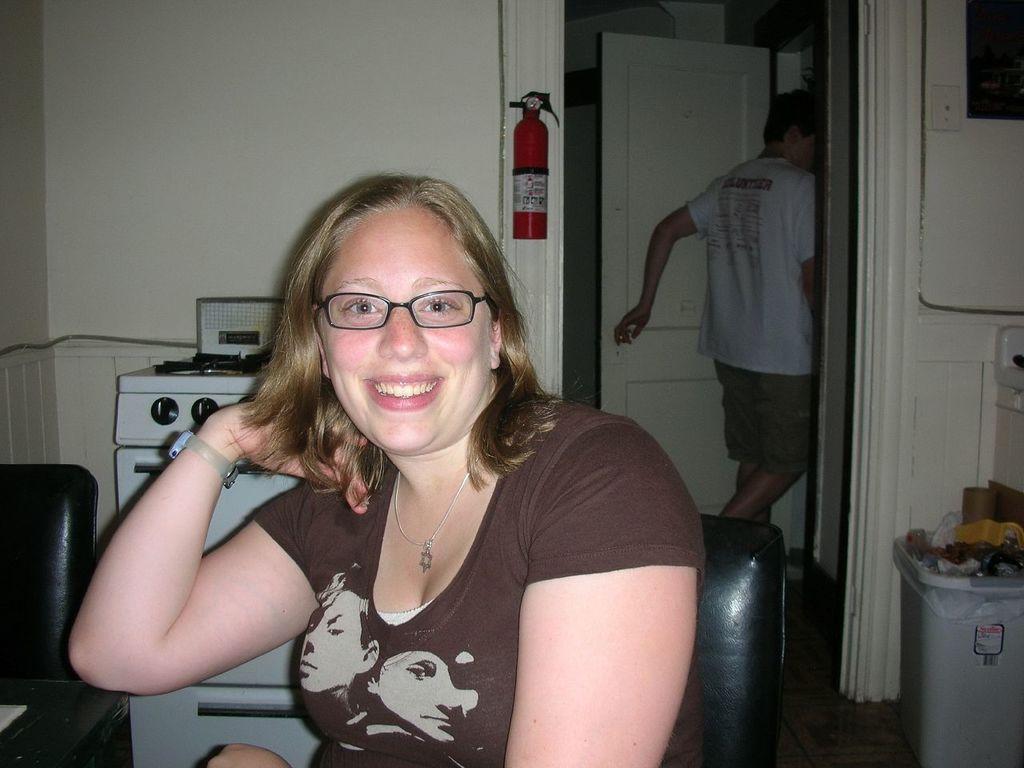In one or two sentences, can you explain what this image depicts? There is a woman in brown color t-shirt smiling and sitting on a chair near a stove and table. In the background, there is a dustbin on the floor, there is a person in white color t-shirt walking near a door and there is white wall. 